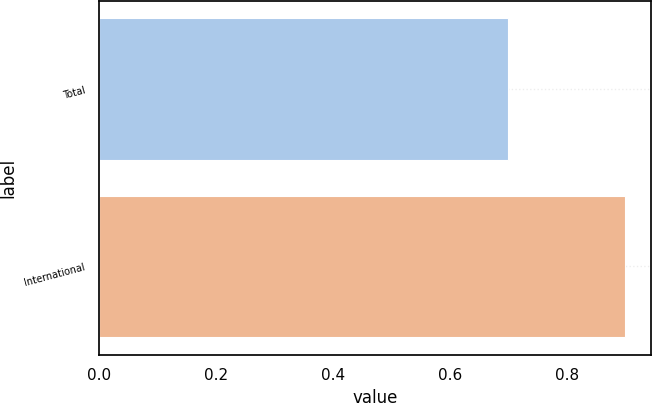<chart> <loc_0><loc_0><loc_500><loc_500><bar_chart><fcel>Total<fcel>International<nl><fcel>0.7<fcel>0.9<nl></chart> 